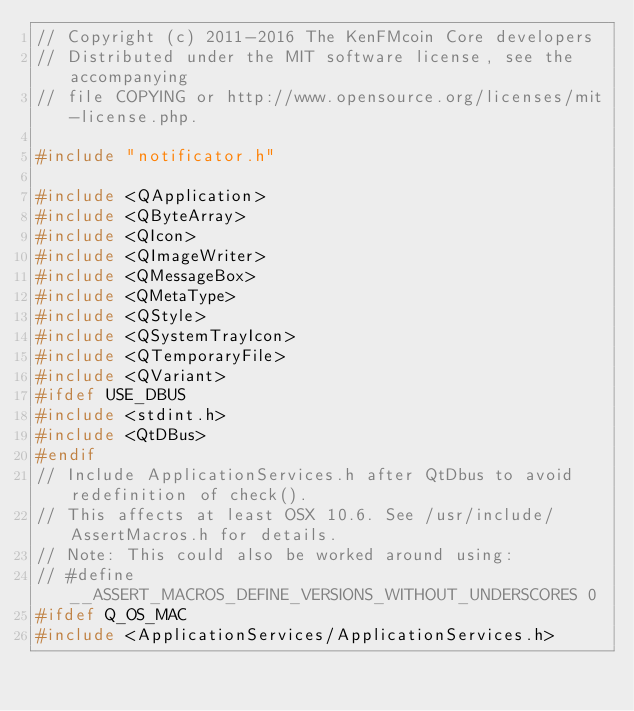Convert code to text. <code><loc_0><loc_0><loc_500><loc_500><_C++_>// Copyright (c) 2011-2016 The KenFMcoin Core developers
// Distributed under the MIT software license, see the accompanying
// file COPYING or http://www.opensource.org/licenses/mit-license.php.

#include "notificator.h"

#include <QApplication>
#include <QByteArray>
#include <QIcon>
#include <QImageWriter>
#include <QMessageBox>
#include <QMetaType>
#include <QStyle>
#include <QSystemTrayIcon>
#include <QTemporaryFile>
#include <QVariant>
#ifdef USE_DBUS
#include <stdint.h>
#include <QtDBus>
#endif
// Include ApplicationServices.h after QtDbus to avoid redefinition of check().
// This affects at least OSX 10.6. See /usr/include/AssertMacros.h for details.
// Note: This could also be worked around using:
// #define __ASSERT_MACROS_DEFINE_VERSIONS_WITHOUT_UNDERSCORES 0
#ifdef Q_OS_MAC
#include <ApplicationServices/ApplicationServices.h></code> 